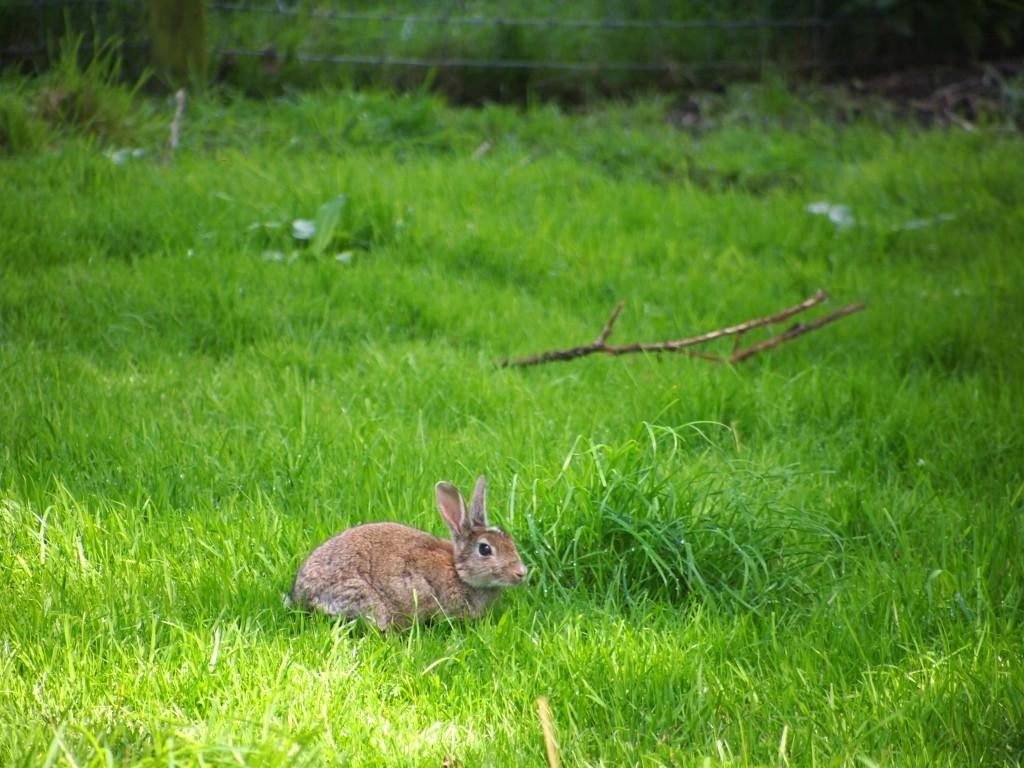Could you give a brief overview of what you see in this image? This picture is clicked outside. In the foreground can see the rabbit and we can see there are some objects and we can see the green grass. 